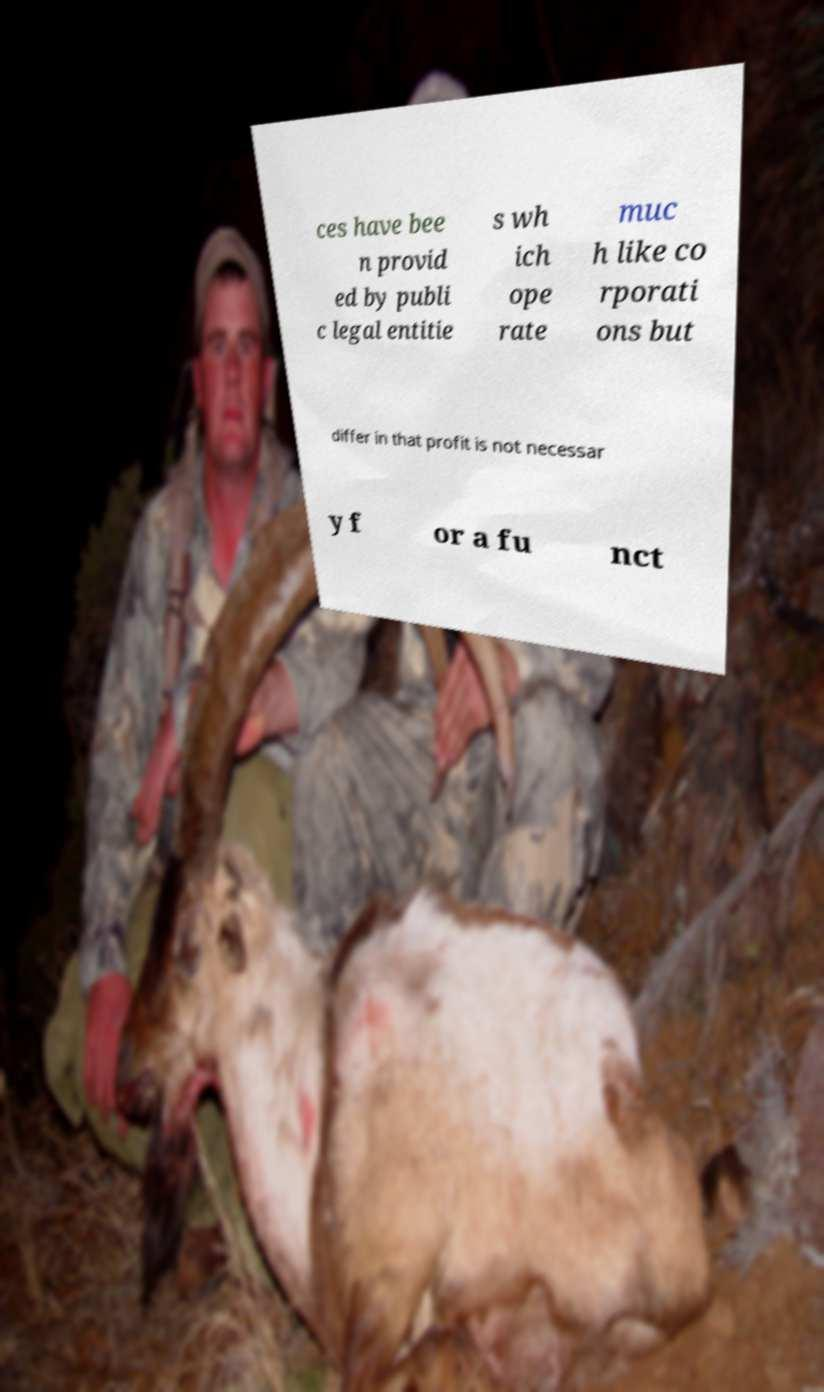I need the written content from this picture converted into text. Can you do that? ces have bee n provid ed by publi c legal entitie s wh ich ope rate muc h like co rporati ons but differ in that profit is not necessar y f or a fu nct 